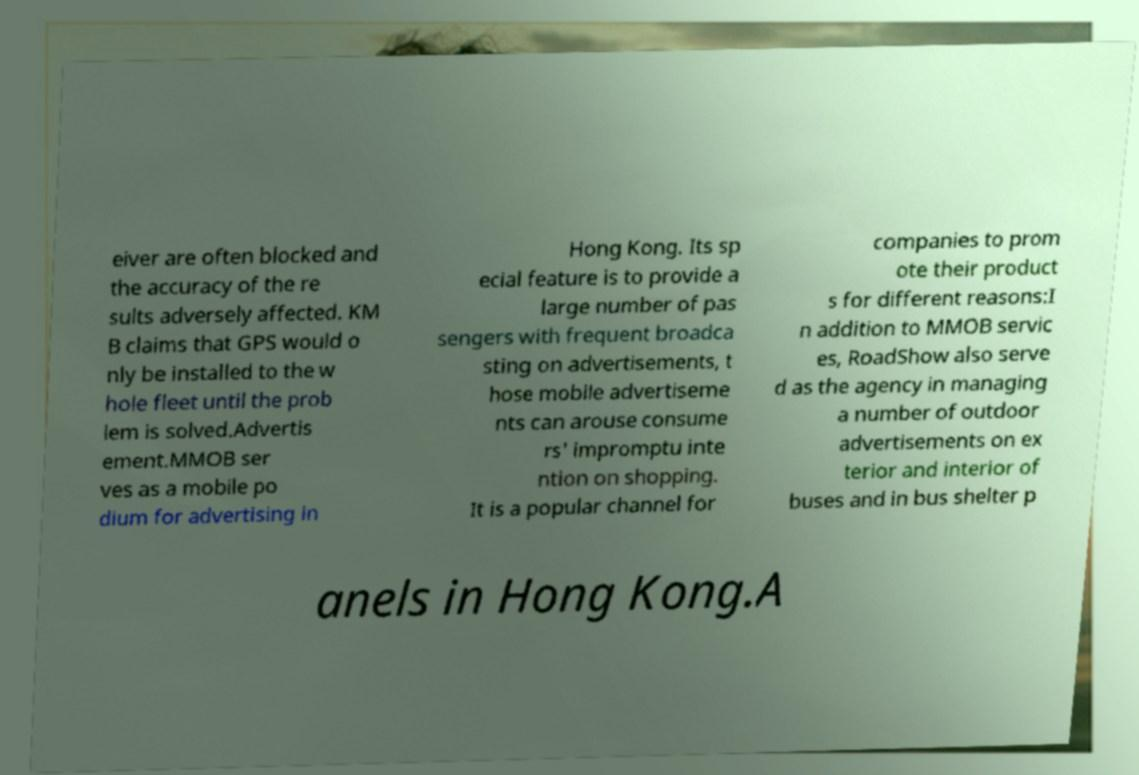Can you accurately transcribe the text from the provided image for me? eiver are often blocked and the accuracy of the re sults adversely affected. KM B claims that GPS would o nly be installed to the w hole fleet until the prob lem is solved.Advertis ement.MMOB ser ves as a mobile po dium for advertising in Hong Kong. Its sp ecial feature is to provide a large number of pas sengers with frequent broadca sting on advertisements, t hose mobile advertiseme nts can arouse consume rs' impromptu inte ntion on shopping. It is a popular channel for companies to prom ote their product s for different reasons:I n addition to MMOB servic es, RoadShow also serve d as the agency in managing a number of outdoor advertisements on ex terior and interior of buses and in bus shelter p anels in Hong Kong.A 